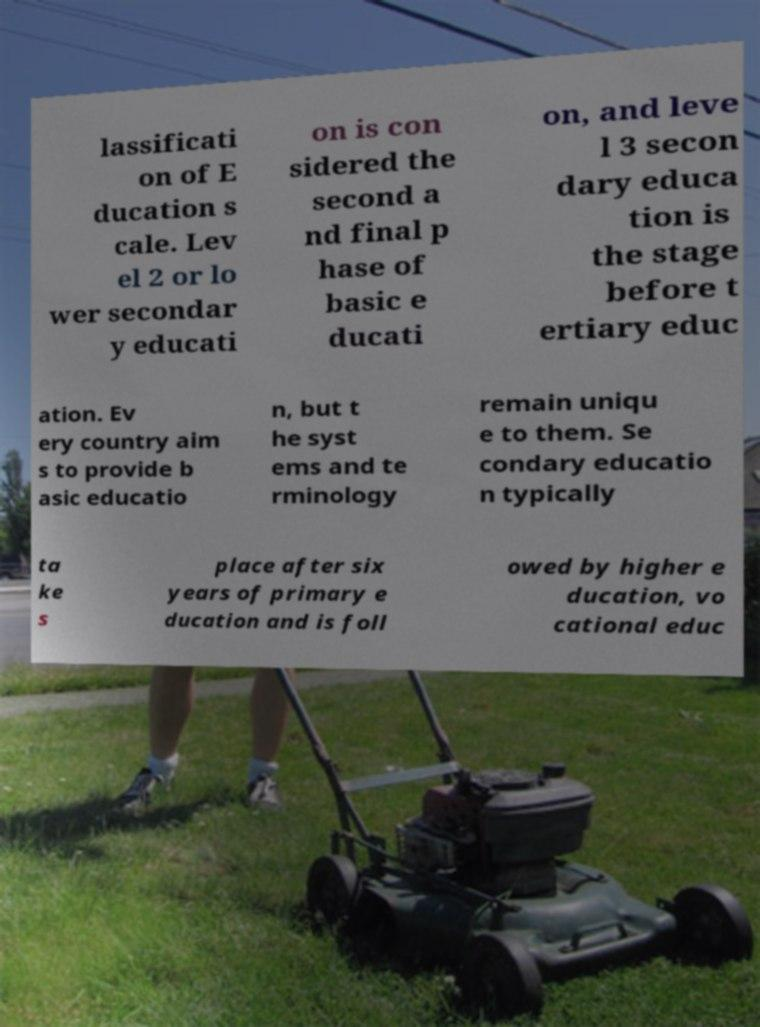Could you extract and type out the text from this image? lassificati on of E ducation s cale. Lev el 2 or lo wer secondar y educati on is con sidered the second a nd final p hase of basic e ducati on, and leve l 3 secon dary educa tion is the stage before t ertiary educ ation. Ev ery country aim s to provide b asic educatio n, but t he syst ems and te rminology remain uniqu e to them. Se condary educatio n typically ta ke s place after six years of primary e ducation and is foll owed by higher e ducation, vo cational educ 